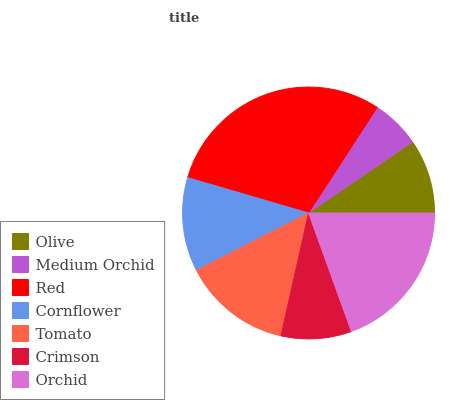Is Medium Orchid the minimum?
Answer yes or no. Yes. Is Red the maximum?
Answer yes or no. Yes. Is Red the minimum?
Answer yes or no. No. Is Medium Orchid the maximum?
Answer yes or no. No. Is Red greater than Medium Orchid?
Answer yes or no. Yes. Is Medium Orchid less than Red?
Answer yes or no. Yes. Is Medium Orchid greater than Red?
Answer yes or no. No. Is Red less than Medium Orchid?
Answer yes or no. No. Is Cornflower the high median?
Answer yes or no. Yes. Is Cornflower the low median?
Answer yes or no. Yes. Is Tomato the high median?
Answer yes or no. No. Is Olive the low median?
Answer yes or no. No. 